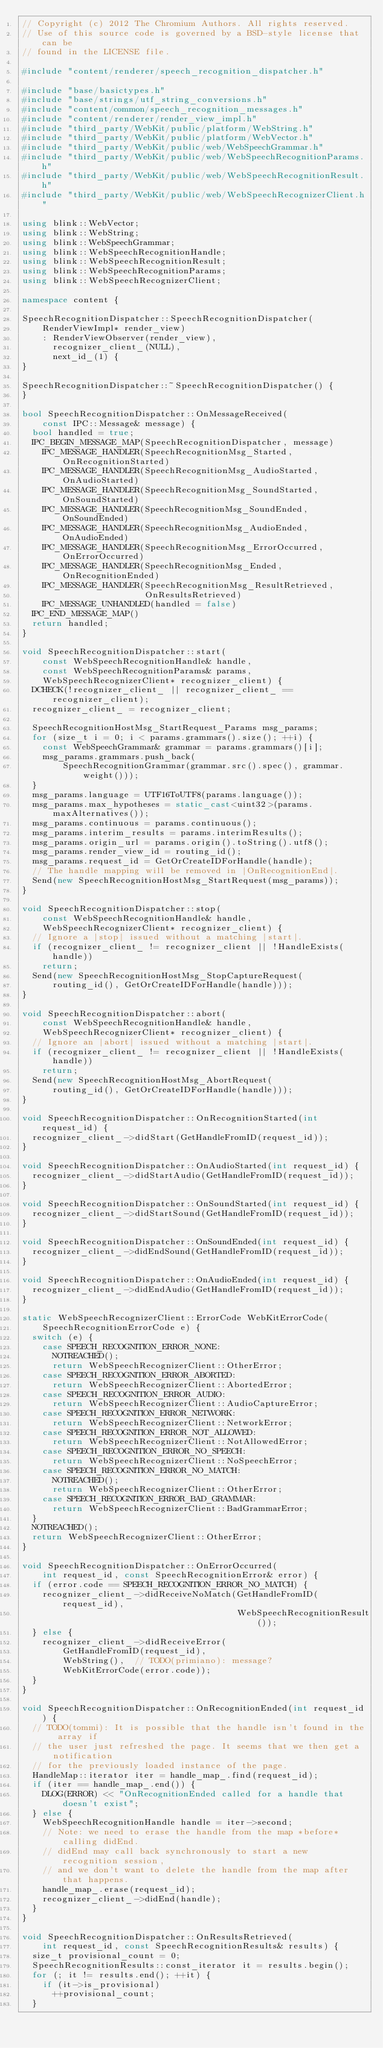<code> <loc_0><loc_0><loc_500><loc_500><_C++_>// Copyright (c) 2012 The Chromium Authors. All rights reserved.
// Use of this source code is governed by a BSD-style license that can be
// found in the LICENSE file.

#include "content/renderer/speech_recognition_dispatcher.h"

#include "base/basictypes.h"
#include "base/strings/utf_string_conversions.h"
#include "content/common/speech_recognition_messages.h"
#include "content/renderer/render_view_impl.h"
#include "third_party/WebKit/public/platform/WebString.h"
#include "third_party/WebKit/public/platform/WebVector.h"
#include "third_party/WebKit/public/web/WebSpeechGrammar.h"
#include "third_party/WebKit/public/web/WebSpeechRecognitionParams.h"
#include "third_party/WebKit/public/web/WebSpeechRecognitionResult.h"
#include "third_party/WebKit/public/web/WebSpeechRecognizerClient.h"

using blink::WebVector;
using blink::WebString;
using blink::WebSpeechGrammar;
using blink::WebSpeechRecognitionHandle;
using blink::WebSpeechRecognitionResult;
using blink::WebSpeechRecognitionParams;
using blink::WebSpeechRecognizerClient;

namespace content {

SpeechRecognitionDispatcher::SpeechRecognitionDispatcher(
    RenderViewImpl* render_view)
    : RenderViewObserver(render_view),
      recognizer_client_(NULL),
      next_id_(1) {
}

SpeechRecognitionDispatcher::~SpeechRecognitionDispatcher() {
}

bool SpeechRecognitionDispatcher::OnMessageReceived(
    const IPC::Message& message) {
  bool handled = true;
  IPC_BEGIN_MESSAGE_MAP(SpeechRecognitionDispatcher, message)
    IPC_MESSAGE_HANDLER(SpeechRecognitionMsg_Started, OnRecognitionStarted)
    IPC_MESSAGE_HANDLER(SpeechRecognitionMsg_AudioStarted, OnAudioStarted)
    IPC_MESSAGE_HANDLER(SpeechRecognitionMsg_SoundStarted, OnSoundStarted)
    IPC_MESSAGE_HANDLER(SpeechRecognitionMsg_SoundEnded, OnSoundEnded)
    IPC_MESSAGE_HANDLER(SpeechRecognitionMsg_AudioEnded, OnAudioEnded)
    IPC_MESSAGE_HANDLER(SpeechRecognitionMsg_ErrorOccurred, OnErrorOccurred)
    IPC_MESSAGE_HANDLER(SpeechRecognitionMsg_Ended, OnRecognitionEnded)
    IPC_MESSAGE_HANDLER(SpeechRecognitionMsg_ResultRetrieved,
                        OnResultsRetrieved)
    IPC_MESSAGE_UNHANDLED(handled = false)
  IPC_END_MESSAGE_MAP()
  return handled;
}

void SpeechRecognitionDispatcher::start(
    const WebSpeechRecognitionHandle& handle,
    const WebSpeechRecognitionParams& params,
    WebSpeechRecognizerClient* recognizer_client) {
  DCHECK(!recognizer_client_ || recognizer_client_ == recognizer_client);
  recognizer_client_ = recognizer_client;

  SpeechRecognitionHostMsg_StartRequest_Params msg_params;
  for (size_t i = 0; i < params.grammars().size(); ++i) {
    const WebSpeechGrammar& grammar = params.grammars()[i];
    msg_params.grammars.push_back(
        SpeechRecognitionGrammar(grammar.src().spec(), grammar.weight()));
  }
  msg_params.language = UTF16ToUTF8(params.language());
  msg_params.max_hypotheses = static_cast<uint32>(params.maxAlternatives());
  msg_params.continuous = params.continuous();
  msg_params.interim_results = params.interimResults();
  msg_params.origin_url = params.origin().toString().utf8();
  msg_params.render_view_id = routing_id();
  msg_params.request_id = GetOrCreateIDForHandle(handle);
  // The handle mapping will be removed in |OnRecognitionEnd|.
  Send(new SpeechRecognitionHostMsg_StartRequest(msg_params));
}

void SpeechRecognitionDispatcher::stop(
    const WebSpeechRecognitionHandle& handle,
    WebSpeechRecognizerClient* recognizer_client) {
  // Ignore a |stop| issued without a matching |start|.
  if (recognizer_client_ != recognizer_client || !HandleExists(handle))
    return;
  Send(new SpeechRecognitionHostMsg_StopCaptureRequest(
      routing_id(), GetOrCreateIDForHandle(handle)));
}

void SpeechRecognitionDispatcher::abort(
    const WebSpeechRecognitionHandle& handle,
    WebSpeechRecognizerClient* recognizer_client) {
  // Ignore an |abort| issued without a matching |start|.
  if (recognizer_client_ != recognizer_client || !HandleExists(handle))
    return;
  Send(new SpeechRecognitionHostMsg_AbortRequest(
      routing_id(), GetOrCreateIDForHandle(handle)));
}

void SpeechRecognitionDispatcher::OnRecognitionStarted(int request_id) {
  recognizer_client_->didStart(GetHandleFromID(request_id));
}

void SpeechRecognitionDispatcher::OnAudioStarted(int request_id) {
  recognizer_client_->didStartAudio(GetHandleFromID(request_id));
}

void SpeechRecognitionDispatcher::OnSoundStarted(int request_id) {
  recognizer_client_->didStartSound(GetHandleFromID(request_id));
}

void SpeechRecognitionDispatcher::OnSoundEnded(int request_id) {
  recognizer_client_->didEndSound(GetHandleFromID(request_id));
}

void SpeechRecognitionDispatcher::OnAudioEnded(int request_id) {
  recognizer_client_->didEndAudio(GetHandleFromID(request_id));
}

static WebSpeechRecognizerClient::ErrorCode WebKitErrorCode(
    SpeechRecognitionErrorCode e) {
  switch (e) {
    case SPEECH_RECOGNITION_ERROR_NONE:
      NOTREACHED();
      return WebSpeechRecognizerClient::OtherError;
    case SPEECH_RECOGNITION_ERROR_ABORTED:
      return WebSpeechRecognizerClient::AbortedError;
    case SPEECH_RECOGNITION_ERROR_AUDIO:
      return WebSpeechRecognizerClient::AudioCaptureError;
    case SPEECH_RECOGNITION_ERROR_NETWORK:
      return WebSpeechRecognizerClient::NetworkError;
    case SPEECH_RECOGNITION_ERROR_NOT_ALLOWED:
      return WebSpeechRecognizerClient::NotAllowedError;
    case SPEECH_RECOGNITION_ERROR_NO_SPEECH:
      return WebSpeechRecognizerClient::NoSpeechError;
    case SPEECH_RECOGNITION_ERROR_NO_MATCH:
      NOTREACHED();
      return WebSpeechRecognizerClient::OtherError;
    case SPEECH_RECOGNITION_ERROR_BAD_GRAMMAR:
      return WebSpeechRecognizerClient::BadGrammarError;
  }
  NOTREACHED();
  return WebSpeechRecognizerClient::OtherError;
}

void SpeechRecognitionDispatcher::OnErrorOccurred(
    int request_id, const SpeechRecognitionError& error) {
  if (error.code == SPEECH_RECOGNITION_ERROR_NO_MATCH) {
    recognizer_client_->didReceiveNoMatch(GetHandleFromID(request_id),
                                          WebSpeechRecognitionResult());
  } else {
    recognizer_client_->didReceiveError(
        GetHandleFromID(request_id),
        WebString(),  // TODO(primiano): message?
        WebKitErrorCode(error.code));
  }
}

void SpeechRecognitionDispatcher::OnRecognitionEnded(int request_id) {
  // TODO(tommi): It is possible that the handle isn't found in the array if
  // the user just refreshed the page. It seems that we then get a notification
  // for the previously loaded instance of the page.
  HandleMap::iterator iter = handle_map_.find(request_id);
  if (iter == handle_map_.end()) {
    DLOG(ERROR) << "OnRecognitionEnded called for a handle that doesn't exist";
  } else {
    WebSpeechRecognitionHandle handle = iter->second;
    // Note: we need to erase the handle from the map *before* calling didEnd.
    // didEnd may call back synchronously to start a new recognition session,
    // and we don't want to delete the handle from the map after that happens.
    handle_map_.erase(request_id);
    recognizer_client_->didEnd(handle);
  }
}

void SpeechRecognitionDispatcher::OnResultsRetrieved(
    int request_id, const SpeechRecognitionResults& results) {
  size_t provisional_count = 0;
  SpeechRecognitionResults::const_iterator it = results.begin();
  for (; it != results.end(); ++it) {
    if (it->is_provisional)
      ++provisional_count;
  }
</code> 